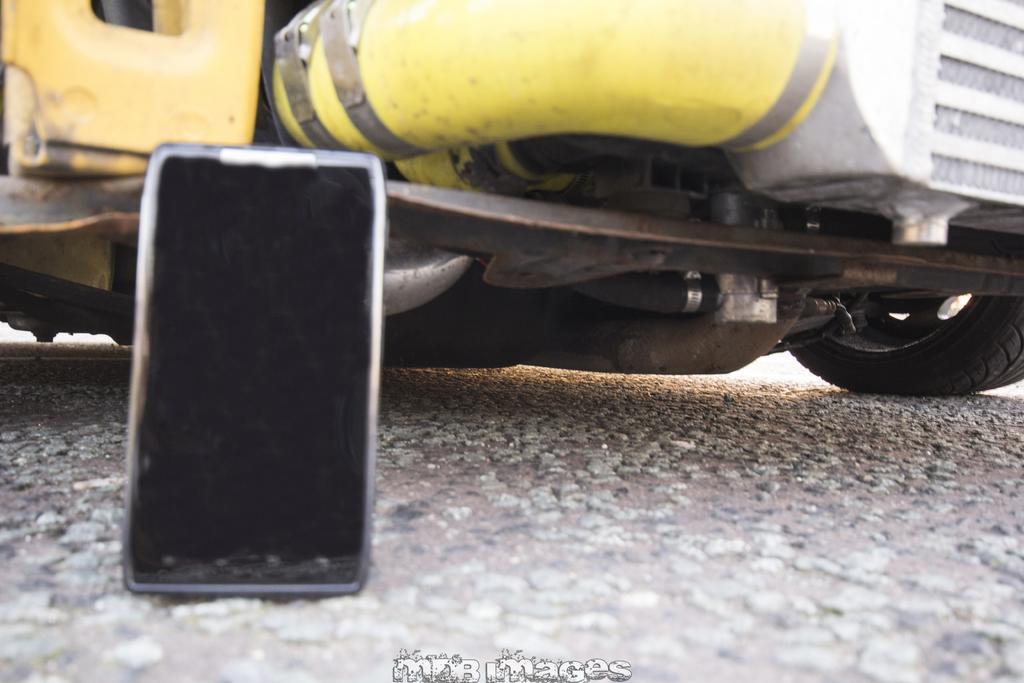Can you describe this image briefly? In this image we can see mobile. In the back we can see part of a vehicle. At the bottom there is text on the image. 